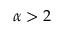<formula> <loc_0><loc_0><loc_500><loc_500>\alpha > 2</formula> 